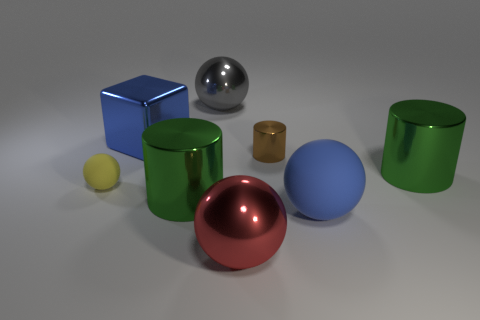There is another object that is the same color as the large rubber object; what is its shape?
Make the answer very short. Cube. What is the shape of the big green thing that is to the left of the big ball right of the small metallic cylinder?
Provide a short and direct response. Cylinder. What number of other things are there of the same material as the blue block
Provide a short and direct response. 5. Are there any other things that are the same size as the gray shiny object?
Make the answer very short. Yes. Is the number of large purple rubber spheres greater than the number of blue cubes?
Provide a short and direct response. No. How big is the rubber sphere that is left of the large green metallic cylinder that is in front of the yellow thing in front of the small shiny cylinder?
Provide a short and direct response. Small. Is the size of the blue block the same as the blue rubber object that is on the right side of the small rubber thing?
Ensure brevity in your answer.  Yes. Are there fewer gray shiny balls that are in front of the blue metal object than red things?
Ensure brevity in your answer.  Yes. What number of balls have the same color as the big metal cube?
Provide a short and direct response. 1. Are there fewer big blue rubber spheres than rubber balls?
Give a very brief answer. Yes. 